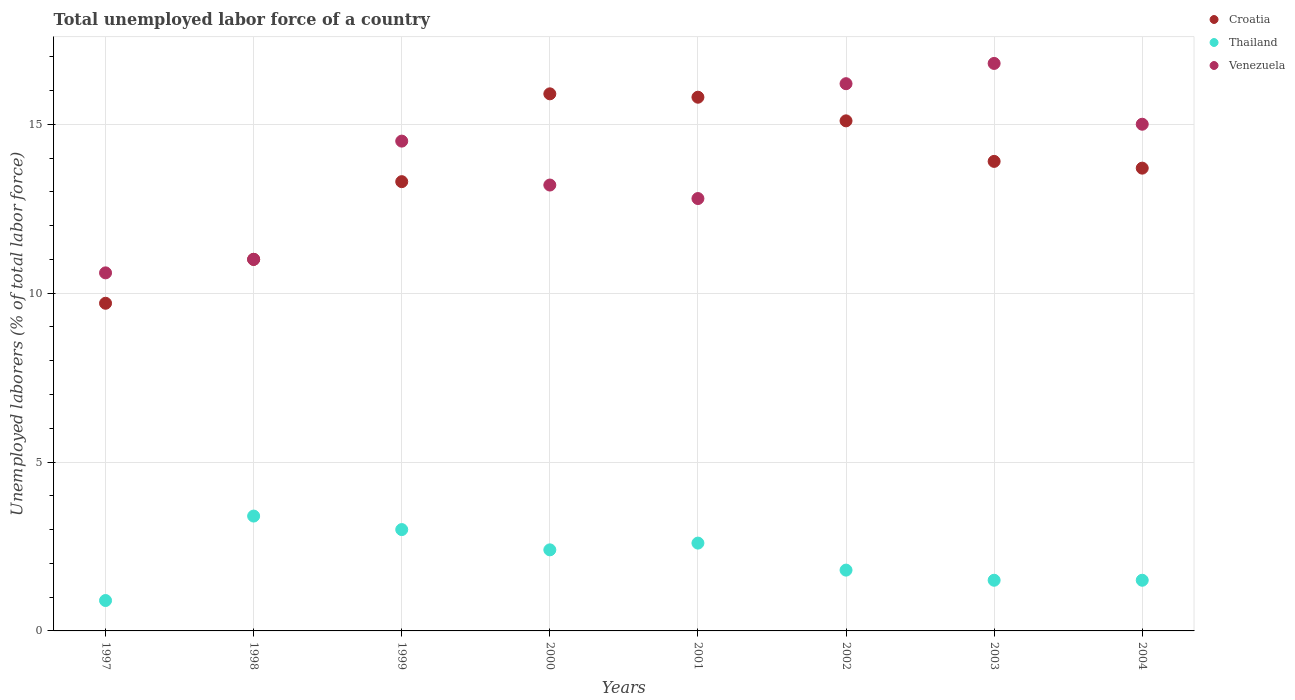Across all years, what is the maximum total unemployed labor force in Thailand?
Your response must be concise. 3.4. Across all years, what is the minimum total unemployed labor force in Croatia?
Provide a short and direct response. 9.7. In which year was the total unemployed labor force in Croatia maximum?
Make the answer very short. 2000. In which year was the total unemployed labor force in Thailand minimum?
Offer a very short reply. 1997. What is the total total unemployed labor force in Croatia in the graph?
Offer a very short reply. 108.4. What is the difference between the total unemployed labor force in Croatia in 2001 and that in 2003?
Your answer should be very brief. 1.9. What is the difference between the total unemployed labor force in Croatia in 1997 and the total unemployed labor force in Venezuela in 2001?
Make the answer very short. -3.1. What is the average total unemployed labor force in Venezuela per year?
Your answer should be very brief. 13.76. In how many years, is the total unemployed labor force in Thailand greater than 16 %?
Provide a succinct answer. 0. What is the ratio of the total unemployed labor force in Thailand in 2001 to that in 2003?
Provide a short and direct response. 1.73. Is the difference between the total unemployed labor force in Thailand in 1998 and 2003 greater than the difference between the total unemployed labor force in Venezuela in 1998 and 2003?
Your answer should be compact. Yes. What is the difference between the highest and the second highest total unemployed labor force in Croatia?
Make the answer very short. 0.1. What is the difference between the highest and the lowest total unemployed labor force in Thailand?
Ensure brevity in your answer.  2.5. In how many years, is the total unemployed labor force in Croatia greater than the average total unemployed labor force in Croatia taken over all years?
Ensure brevity in your answer.  5. Is the sum of the total unemployed labor force in Venezuela in 1999 and 2000 greater than the maximum total unemployed labor force in Croatia across all years?
Provide a short and direct response. Yes. Does the total unemployed labor force in Thailand monotonically increase over the years?
Provide a short and direct response. No. Is the total unemployed labor force in Thailand strictly greater than the total unemployed labor force in Croatia over the years?
Your answer should be compact. No. How many dotlines are there?
Provide a short and direct response. 3. How many years are there in the graph?
Make the answer very short. 8. What is the difference between two consecutive major ticks on the Y-axis?
Your answer should be very brief. 5. Does the graph contain grids?
Provide a short and direct response. Yes. Where does the legend appear in the graph?
Ensure brevity in your answer.  Top right. How are the legend labels stacked?
Offer a very short reply. Vertical. What is the title of the graph?
Your response must be concise. Total unemployed labor force of a country. What is the label or title of the Y-axis?
Provide a short and direct response. Unemployed laborers (% of total labor force). What is the Unemployed laborers (% of total labor force) of Croatia in 1997?
Provide a succinct answer. 9.7. What is the Unemployed laborers (% of total labor force) of Thailand in 1997?
Provide a short and direct response. 0.9. What is the Unemployed laborers (% of total labor force) of Venezuela in 1997?
Make the answer very short. 10.6. What is the Unemployed laborers (% of total labor force) in Croatia in 1998?
Keep it short and to the point. 11. What is the Unemployed laborers (% of total labor force) in Thailand in 1998?
Ensure brevity in your answer.  3.4. What is the Unemployed laborers (% of total labor force) of Venezuela in 1998?
Keep it short and to the point. 11. What is the Unemployed laborers (% of total labor force) of Croatia in 1999?
Provide a succinct answer. 13.3. What is the Unemployed laborers (% of total labor force) in Thailand in 1999?
Offer a terse response. 3. What is the Unemployed laborers (% of total labor force) in Croatia in 2000?
Keep it short and to the point. 15.9. What is the Unemployed laborers (% of total labor force) in Thailand in 2000?
Provide a succinct answer. 2.4. What is the Unemployed laborers (% of total labor force) in Venezuela in 2000?
Your response must be concise. 13.2. What is the Unemployed laborers (% of total labor force) of Croatia in 2001?
Your answer should be very brief. 15.8. What is the Unemployed laborers (% of total labor force) of Thailand in 2001?
Your response must be concise. 2.6. What is the Unemployed laborers (% of total labor force) of Venezuela in 2001?
Your response must be concise. 12.8. What is the Unemployed laborers (% of total labor force) of Croatia in 2002?
Offer a very short reply. 15.1. What is the Unemployed laborers (% of total labor force) in Thailand in 2002?
Your answer should be very brief. 1.8. What is the Unemployed laborers (% of total labor force) of Venezuela in 2002?
Your response must be concise. 16.2. What is the Unemployed laborers (% of total labor force) of Croatia in 2003?
Make the answer very short. 13.9. What is the Unemployed laborers (% of total labor force) in Venezuela in 2003?
Ensure brevity in your answer.  16.8. What is the Unemployed laborers (% of total labor force) of Croatia in 2004?
Provide a short and direct response. 13.7. Across all years, what is the maximum Unemployed laborers (% of total labor force) of Croatia?
Your answer should be compact. 15.9. Across all years, what is the maximum Unemployed laborers (% of total labor force) of Thailand?
Give a very brief answer. 3.4. Across all years, what is the maximum Unemployed laborers (% of total labor force) of Venezuela?
Make the answer very short. 16.8. Across all years, what is the minimum Unemployed laborers (% of total labor force) of Croatia?
Your response must be concise. 9.7. Across all years, what is the minimum Unemployed laborers (% of total labor force) in Thailand?
Your answer should be compact. 0.9. Across all years, what is the minimum Unemployed laborers (% of total labor force) in Venezuela?
Make the answer very short. 10.6. What is the total Unemployed laborers (% of total labor force) of Croatia in the graph?
Your answer should be very brief. 108.4. What is the total Unemployed laborers (% of total labor force) in Venezuela in the graph?
Offer a very short reply. 110.1. What is the difference between the Unemployed laborers (% of total labor force) in Thailand in 1997 and that in 1998?
Provide a short and direct response. -2.5. What is the difference between the Unemployed laborers (% of total labor force) in Venezuela in 1997 and that in 1998?
Your answer should be very brief. -0.4. What is the difference between the Unemployed laborers (% of total labor force) in Thailand in 1997 and that in 1999?
Provide a short and direct response. -2.1. What is the difference between the Unemployed laborers (% of total labor force) of Venezuela in 1997 and that in 1999?
Provide a succinct answer. -3.9. What is the difference between the Unemployed laborers (% of total labor force) in Thailand in 1997 and that in 2000?
Provide a succinct answer. -1.5. What is the difference between the Unemployed laborers (% of total labor force) of Venezuela in 1997 and that in 2000?
Keep it short and to the point. -2.6. What is the difference between the Unemployed laborers (% of total labor force) in Croatia in 1997 and that in 2001?
Your answer should be compact. -6.1. What is the difference between the Unemployed laborers (% of total labor force) of Thailand in 1997 and that in 2001?
Provide a succinct answer. -1.7. What is the difference between the Unemployed laborers (% of total labor force) of Venezuela in 1997 and that in 2002?
Your response must be concise. -5.6. What is the difference between the Unemployed laborers (% of total labor force) in Croatia in 1997 and that in 2003?
Give a very brief answer. -4.2. What is the difference between the Unemployed laborers (% of total labor force) in Thailand in 1997 and that in 2003?
Your answer should be compact. -0.6. What is the difference between the Unemployed laborers (% of total labor force) of Croatia in 1997 and that in 2004?
Keep it short and to the point. -4. What is the difference between the Unemployed laborers (% of total labor force) of Venezuela in 1997 and that in 2004?
Keep it short and to the point. -4.4. What is the difference between the Unemployed laborers (% of total labor force) of Thailand in 1998 and that in 1999?
Offer a terse response. 0.4. What is the difference between the Unemployed laborers (% of total labor force) of Croatia in 1998 and that in 2001?
Offer a very short reply. -4.8. What is the difference between the Unemployed laborers (% of total labor force) in Croatia in 1998 and that in 2002?
Your answer should be very brief. -4.1. What is the difference between the Unemployed laborers (% of total labor force) in Venezuela in 1998 and that in 2002?
Provide a short and direct response. -5.2. What is the difference between the Unemployed laborers (% of total labor force) of Croatia in 1998 and that in 2004?
Keep it short and to the point. -2.7. What is the difference between the Unemployed laborers (% of total labor force) in Venezuela in 1998 and that in 2004?
Provide a succinct answer. -4. What is the difference between the Unemployed laborers (% of total labor force) of Thailand in 1999 and that in 2000?
Ensure brevity in your answer.  0.6. What is the difference between the Unemployed laborers (% of total labor force) in Croatia in 1999 and that in 2001?
Provide a succinct answer. -2.5. What is the difference between the Unemployed laborers (% of total labor force) of Thailand in 1999 and that in 2002?
Offer a terse response. 1.2. What is the difference between the Unemployed laborers (% of total labor force) of Croatia in 1999 and that in 2003?
Provide a short and direct response. -0.6. What is the difference between the Unemployed laborers (% of total labor force) of Venezuela in 1999 and that in 2003?
Provide a short and direct response. -2.3. What is the difference between the Unemployed laborers (% of total labor force) of Thailand in 1999 and that in 2004?
Your response must be concise. 1.5. What is the difference between the Unemployed laborers (% of total labor force) in Venezuela in 1999 and that in 2004?
Ensure brevity in your answer.  -0.5. What is the difference between the Unemployed laborers (% of total labor force) of Thailand in 2000 and that in 2002?
Your answer should be compact. 0.6. What is the difference between the Unemployed laborers (% of total labor force) of Venezuela in 2000 and that in 2002?
Offer a very short reply. -3. What is the difference between the Unemployed laborers (% of total labor force) in Croatia in 2000 and that in 2003?
Your response must be concise. 2. What is the difference between the Unemployed laborers (% of total labor force) of Venezuela in 2000 and that in 2003?
Your answer should be very brief. -3.6. What is the difference between the Unemployed laborers (% of total labor force) in Croatia in 2000 and that in 2004?
Your response must be concise. 2.2. What is the difference between the Unemployed laborers (% of total labor force) in Thailand in 2000 and that in 2004?
Offer a terse response. 0.9. What is the difference between the Unemployed laborers (% of total labor force) in Venezuela in 2000 and that in 2004?
Offer a terse response. -1.8. What is the difference between the Unemployed laborers (% of total labor force) of Thailand in 2001 and that in 2002?
Give a very brief answer. 0.8. What is the difference between the Unemployed laborers (% of total labor force) of Venezuela in 2001 and that in 2002?
Give a very brief answer. -3.4. What is the difference between the Unemployed laborers (% of total labor force) of Croatia in 2001 and that in 2003?
Ensure brevity in your answer.  1.9. What is the difference between the Unemployed laborers (% of total labor force) in Thailand in 2001 and that in 2003?
Provide a succinct answer. 1.1. What is the difference between the Unemployed laborers (% of total labor force) in Thailand in 2002 and that in 2003?
Offer a very short reply. 0.3. What is the difference between the Unemployed laborers (% of total labor force) in Croatia in 2002 and that in 2004?
Give a very brief answer. 1.4. What is the difference between the Unemployed laborers (% of total labor force) of Venezuela in 2002 and that in 2004?
Offer a terse response. 1.2. What is the difference between the Unemployed laborers (% of total labor force) in Thailand in 2003 and that in 2004?
Provide a succinct answer. 0. What is the difference between the Unemployed laborers (% of total labor force) in Thailand in 1997 and the Unemployed laborers (% of total labor force) in Venezuela in 1998?
Keep it short and to the point. -10.1. What is the difference between the Unemployed laborers (% of total labor force) in Croatia in 1997 and the Unemployed laborers (% of total labor force) in Thailand in 1999?
Provide a short and direct response. 6.7. What is the difference between the Unemployed laborers (% of total labor force) in Croatia in 1997 and the Unemployed laborers (% of total labor force) in Venezuela in 1999?
Make the answer very short. -4.8. What is the difference between the Unemployed laborers (% of total labor force) in Thailand in 1997 and the Unemployed laborers (% of total labor force) in Venezuela in 1999?
Your answer should be very brief. -13.6. What is the difference between the Unemployed laborers (% of total labor force) in Croatia in 1997 and the Unemployed laborers (% of total labor force) in Venezuela in 2000?
Ensure brevity in your answer.  -3.5. What is the difference between the Unemployed laborers (% of total labor force) of Thailand in 1997 and the Unemployed laborers (% of total labor force) of Venezuela in 2001?
Offer a very short reply. -11.9. What is the difference between the Unemployed laborers (% of total labor force) in Croatia in 1997 and the Unemployed laborers (% of total labor force) in Thailand in 2002?
Provide a succinct answer. 7.9. What is the difference between the Unemployed laborers (% of total labor force) in Croatia in 1997 and the Unemployed laborers (% of total labor force) in Venezuela in 2002?
Your answer should be compact. -6.5. What is the difference between the Unemployed laborers (% of total labor force) of Thailand in 1997 and the Unemployed laborers (% of total labor force) of Venezuela in 2002?
Make the answer very short. -15.3. What is the difference between the Unemployed laborers (% of total labor force) in Croatia in 1997 and the Unemployed laborers (% of total labor force) in Venezuela in 2003?
Your response must be concise. -7.1. What is the difference between the Unemployed laborers (% of total labor force) in Thailand in 1997 and the Unemployed laborers (% of total labor force) in Venezuela in 2003?
Provide a short and direct response. -15.9. What is the difference between the Unemployed laborers (% of total labor force) in Croatia in 1997 and the Unemployed laborers (% of total labor force) in Venezuela in 2004?
Give a very brief answer. -5.3. What is the difference between the Unemployed laborers (% of total labor force) in Thailand in 1997 and the Unemployed laborers (% of total labor force) in Venezuela in 2004?
Keep it short and to the point. -14.1. What is the difference between the Unemployed laborers (% of total labor force) in Croatia in 1998 and the Unemployed laborers (% of total labor force) in Venezuela in 1999?
Provide a short and direct response. -3.5. What is the difference between the Unemployed laborers (% of total labor force) in Thailand in 1998 and the Unemployed laborers (% of total labor force) in Venezuela in 1999?
Your answer should be very brief. -11.1. What is the difference between the Unemployed laborers (% of total labor force) in Croatia in 1998 and the Unemployed laborers (% of total labor force) in Venezuela in 2000?
Your response must be concise. -2.2. What is the difference between the Unemployed laborers (% of total labor force) of Croatia in 1998 and the Unemployed laborers (% of total labor force) of Venezuela in 2001?
Provide a succinct answer. -1.8. What is the difference between the Unemployed laborers (% of total labor force) in Croatia in 1998 and the Unemployed laborers (% of total labor force) in Thailand in 2002?
Your response must be concise. 9.2. What is the difference between the Unemployed laborers (% of total labor force) of Thailand in 1998 and the Unemployed laborers (% of total labor force) of Venezuela in 2002?
Your response must be concise. -12.8. What is the difference between the Unemployed laborers (% of total labor force) of Croatia in 1998 and the Unemployed laborers (% of total labor force) of Venezuela in 2003?
Your response must be concise. -5.8. What is the difference between the Unemployed laborers (% of total labor force) of Croatia in 1998 and the Unemployed laborers (% of total labor force) of Thailand in 2004?
Make the answer very short. 9.5. What is the difference between the Unemployed laborers (% of total labor force) in Thailand in 1998 and the Unemployed laborers (% of total labor force) in Venezuela in 2004?
Keep it short and to the point. -11.6. What is the difference between the Unemployed laborers (% of total labor force) of Croatia in 1999 and the Unemployed laborers (% of total labor force) of Thailand in 2000?
Your answer should be very brief. 10.9. What is the difference between the Unemployed laborers (% of total labor force) in Croatia in 1999 and the Unemployed laborers (% of total labor force) in Thailand in 2001?
Make the answer very short. 10.7. What is the difference between the Unemployed laborers (% of total labor force) of Croatia in 1999 and the Unemployed laborers (% of total labor force) of Venezuela in 2001?
Give a very brief answer. 0.5. What is the difference between the Unemployed laborers (% of total labor force) in Croatia in 1999 and the Unemployed laborers (% of total labor force) in Venezuela in 2002?
Provide a succinct answer. -2.9. What is the difference between the Unemployed laborers (% of total labor force) in Thailand in 1999 and the Unemployed laborers (% of total labor force) in Venezuela in 2002?
Offer a terse response. -13.2. What is the difference between the Unemployed laborers (% of total labor force) of Croatia in 1999 and the Unemployed laborers (% of total labor force) of Thailand in 2003?
Provide a succinct answer. 11.8. What is the difference between the Unemployed laborers (% of total labor force) of Croatia in 1999 and the Unemployed laborers (% of total labor force) of Venezuela in 2003?
Provide a succinct answer. -3.5. What is the difference between the Unemployed laborers (% of total labor force) in Thailand in 1999 and the Unemployed laborers (% of total labor force) in Venezuela in 2003?
Offer a very short reply. -13.8. What is the difference between the Unemployed laborers (% of total labor force) of Croatia in 1999 and the Unemployed laborers (% of total labor force) of Thailand in 2004?
Give a very brief answer. 11.8. What is the difference between the Unemployed laborers (% of total labor force) in Croatia in 1999 and the Unemployed laborers (% of total labor force) in Venezuela in 2004?
Provide a short and direct response. -1.7. What is the difference between the Unemployed laborers (% of total labor force) of Thailand in 2000 and the Unemployed laborers (% of total labor force) of Venezuela in 2001?
Your response must be concise. -10.4. What is the difference between the Unemployed laborers (% of total labor force) of Croatia in 2000 and the Unemployed laborers (% of total labor force) of Thailand in 2003?
Offer a terse response. 14.4. What is the difference between the Unemployed laborers (% of total labor force) in Thailand in 2000 and the Unemployed laborers (% of total labor force) in Venezuela in 2003?
Ensure brevity in your answer.  -14.4. What is the difference between the Unemployed laborers (% of total labor force) in Croatia in 2000 and the Unemployed laborers (% of total labor force) in Thailand in 2004?
Your answer should be compact. 14.4. What is the difference between the Unemployed laborers (% of total labor force) of Croatia in 2000 and the Unemployed laborers (% of total labor force) of Venezuela in 2004?
Keep it short and to the point. 0.9. What is the difference between the Unemployed laborers (% of total labor force) in Thailand in 2000 and the Unemployed laborers (% of total labor force) in Venezuela in 2004?
Keep it short and to the point. -12.6. What is the difference between the Unemployed laborers (% of total labor force) of Croatia in 2001 and the Unemployed laborers (% of total labor force) of Thailand in 2002?
Offer a very short reply. 14. What is the difference between the Unemployed laborers (% of total labor force) in Croatia in 2001 and the Unemployed laborers (% of total labor force) in Venezuela in 2003?
Give a very brief answer. -1. What is the difference between the Unemployed laborers (% of total labor force) of Croatia in 2002 and the Unemployed laborers (% of total labor force) of Venezuela in 2003?
Provide a succinct answer. -1.7. What is the difference between the Unemployed laborers (% of total labor force) in Thailand in 2002 and the Unemployed laborers (% of total labor force) in Venezuela in 2003?
Offer a very short reply. -15. What is the difference between the Unemployed laborers (% of total labor force) of Croatia in 2002 and the Unemployed laborers (% of total labor force) of Thailand in 2004?
Make the answer very short. 13.6. What is the difference between the Unemployed laborers (% of total labor force) in Croatia in 2002 and the Unemployed laborers (% of total labor force) in Venezuela in 2004?
Your answer should be very brief. 0.1. What is the difference between the Unemployed laborers (% of total labor force) in Croatia in 2003 and the Unemployed laborers (% of total labor force) in Thailand in 2004?
Your response must be concise. 12.4. What is the average Unemployed laborers (% of total labor force) of Croatia per year?
Ensure brevity in your answer.  13.55. What is the average Unemployed laborers (% of total labor force) in Thailand per year?
Make the answer very short. 2.14. What is the average Unemployed laborers (% of total labor force) in Venezuela per year?
Your response must be concise. 13.76. In the year 1997, what is the difference between the Unemployed laborers (% of total labor force) in Croatia and Unemployed laborers (% of total labor force) in Thailand?
Your answer should be very brief. 8.8. In the year 1997, what is the difference between the Unemployed laborers (% of total labor force) in Croatia and Unemployed laborers (% of total labor force) in Venezuela?
Provide a succinct answer. -0.9. In the year 1997, what is the difference between the Unemployed laborers (% of total labor force) of Thailand and Unemployed laborers (% of total labor force) of Venezuela?
Provide a succinct answer. -9.7. In the year 1998, what is the difference between the Unemployed laborers (% of total labor force) of Thailand and Unemployed laborers (% of total labor force) of Venezuela?
Offer a terse response. -7.6. In the year 1999, what is the difference between the Unemployed laborers (% of total labor force) in Croatia and Unemployed laborers (% of total labor force) in Venezuela?
Provide a succinct answer. -1.2. In the year 1999, what is the difference between the Unemployed laborers (% of total labor force) in Thailand and Unemployed laborers (% of total labor force) in Venezuela?
Make the answer very short. -11.5. In the year 2000, what is the difference between the Unemployed laborers (% of total labor force) in Croatia and Unemployed laborers (% of total labor force) in Thailand?
Your response must be concise. 13.5. In the year 2000, what is the difference between the Unemployed laborers (% of total labor force) in Croatia and Unemployed laborers (% of total labor force) in Venezuela?
Offer a very short reply. 2.7. In the year 2002, what is the difference between the Unemployed laborers (% of total labor force) of Croatia and Unemployed laborers (% of total labor force) of Venezuela?
Your response must be concise. -1.1. In the year 2002, what is the difference between the Unemployed laborers (% of total labor force) in Thailand and Unemployed laborers (% of total labor force) in Venezuela?
Offer a terse response. -14.4. In the year 2003, what is the difference between the Unemployed laborers (% of total labor force) in Thailand and Unemployed laborers (% of total labor force) in Venezuela?
Keep it short and to the point. -15.3. In the year 2004, what is the difference between the Unemployed laborers (% of total labor force) in Croatia and Unemployed laborers (% of total labor force) in Thailand?
Keep it short and to the point. 12.2. In the year 2004, what is the difference between the Unemployed laborers (% of total labor force) of Thailand and Unemployed laborers (% of total labor force) of Venezuela?
Provide a short and direct response. -13.5. What is the ratio of the Unemployed laborers (% of total labor force) in Croatia in 1997 to that in 1998?
Your response must be concise. 0.88. What is the ratio of the Unemployed laborers (% of total labor force) of Thailand in 1997 to that in 1998?
Your response must be concise. 0.26. What is the ratio of the Unemployed laborers (% of total labor force) of Venezuela in 1997 to that in 1998?
Offer a very short reply. 0.96. What is the ratio of the Unemployed laborers (% of total labor force) of Croatia in 1997 to that in 1999?
Your answer should be very brief. 0.73. What is the ratio of the Unemployed laborers (% of total labor force) in Thailand in 1997 to that in 1999?
Give a very brief answer. 0.3. What is the ratio of the Unemployed laborers (% of total labor force) of Venezuela in 1997 to that in 1999?
Provide a short and direct response. 0.73. What is the ratio of the Unemployed laborers (% of total labor force) of Croatia in 1997 to that in 2000?
Your response must be concise. 0.61. What is the ratio of the Unemployed laborers (% of total labor force) in Venezuela in 1997 to that in 2000?
Your response must be concise. 0.8. What is the ratio of the Unemployed laborers (% of total labor force) in Croatia in 1997 to that in 2001?
Your answer should be very brief. 0.61. What is the ratio of the Unemployed laborers (% of total labor force) in Thailand in 1997 to that in 2001?
Provide a succinct answer. 0.35. What is the ratio of the Unemployed laborers (% of total labor force) of Venezuela in 1997 to that in 2001?
Your answer should be very brief. 0.83. What is the ratio of the Unemployed laborers (% of total labor force) of Croatia in 1997 to that in 2002?
Your answer should be compact. 0.64. What is the ratio of the Unemployed laborers (% of total labor force) in Thailand in 1997 to that in 2002?
Your answer should be very brief. 0.5. What is the ratio of the Unemployed laborers (% of total labor force) in Venezuela in 1997 to that in 2002?
Provide a short and direct response. 0.65. What is the ratio of the Unemployed laborers (% of total labor force) in Croatia in 1997 to that in 2003?
Your answer should be compact. 0.7. What is the ratio of the Unemployed laborers (% of total labor force) of Venezuela in 1997 to that in 2003?
Give a very brief answer. 0.63. What is the ratio of the Unemployed laborers (% of total labor force) of Croatia in 1997 to that in 2004?
Offer a terse response. 0.71. What is the ratio of the Unemployed laborers (% of total labor force) of Venezuela in 1997 to that in 2004?
Your response must be concise. 0.71. What is the ratio of the Unemployed laborers (% of total labor force) of Croatia in 1998 to that in 1999?
Keep it short and to the point. 0.83. What is the ratio of the Unemployed laborers (% of total labor force) of Thailand in 1998 to that in 1999?
Your answer should be very brief. 1.13. What is the ratio of the Unemployed laborers (% of total labor force) in Venezuela in 1998 to that in 1999?
Provide a short and direct response. 0.76. What is the ratio of the Unemployed laborers (% of total labor force) of Croatia in 1998 to that in 2000?
Offer a very short reply. 0.69. What is the ratio of the Unemployed laborers (% of total labor force) in Thailand in 1998 to that in 2000?
Provide a short and direct response. 1.42. What is the ratio of the Unemployed laborers (% of total labor force) in Croatia in 1998 to that in 2001?
Ensure brevity in your answer.  0.7. What is the ratio of the Unemployed laborers (% of total labor force) in Thailand in 1998 to that in 2001?
Your answer should be very brief. 1.31. What is the ratio of the Unemployed laborers (% of total labor force) in Venezuela in 1998 to that in 2001?
Give a very brief answer. 0.86. What is the ratio of the Unemployed laborers (% of total labor force) of Croatia in 1998 to that in 2002?
Give a very brief answer. 0.73. What is the ratio of the Unemployed laborers (% of total labor force) of Thailand in 1998 to that in 2002?
Give a very brief answer. 1.89. What is the ratio of the Unemployed laborers (% of total labor force) of Venezuela in 1998 to that in 2002?
Provide a succinct answer. 0.68. What is the ratio of the Unemployed laborers (% of total labor force) in Croatia in 1998 to that in 2003?
Your response must be concise. 0.79. What is the ratio of the Unemployed laborers (% of total labor force) in Thailand in 1998 to that in 2003?
Your answer should be compact. 2.27. What is the ratio of the Unemployed laborers (% of total labor force) in Venezuela in 1998 to that in 2003?
Your answer should be compact. 0.65. What is the ratio of the Unemployed laborers (% of total labor force) of Croatia in 1998 to that in 2004?
Your response must be concise. 0.8. What is the ratio of the Unemployed laborers (% of total labor force) in Thailand in 1998 to that in 2004?
Offer a terse response. 2.27. What is the ratio of the Unemployed laborers (% of total labor force) in Venezuela in 1998 to that in 2004?
Your response must be concise. 0.73. What is the ratio of the Unemployed laborers (% of total labor force) in Croatia in 1999 to that in 2000?
Make the answer very short. 0.84. What is the ratio of the Unemployed laborers (% of total labor force) in Thailand in 1999 to that in 2000?
Provide a short and direct response. 1.25. What is the ratio of the Unemployed laborers (% of total labor force) of Venezuela in 1999 to that in 2000?
Provide a short and direct response. 1.1. What is the ratio of the Unemployed laborers (% of total labor force) of Croatia in 1999 to that in 2001?
Your answer should be compact. 0.84. What is the ratio of the Unemployed laborers (% of total labor force) in Thailand in 1999 to that in 2001?
Ensure brevity in your answer.  1.15. What is the ratio of the Unemployed laborers (% of total labor force) in Venezuela in 1999 to that in 2001?
Offer a very short reply. 1.13. What is the ratio of the Unemployed laborers (% of total labor force) of Croatia in 1999 to that in 2002?
Offer a terse response. 0.88. What is the ratio of the Unemployed laborers (% of total labor force) of Venezuela in 1999 to that in 2002?
Ensure brevity in your answer.  0.9. What is the ratio of the Unemployed laborers (% of total labor force) in Croatia in 1999 to that in 2003?
Offer a terse response. 0.96. What is the ratio of the Unemployed laborers (% of total labor force) in Thailand in 1999 to that in 2003?
Your answer should be very brief. 2. What is the ratio of the Unemployed laborers (% of total labor force) in Venezuela in 1999 to that in 2003?
Your response must be concise. 0.86. What is the ratio of the Unemployed laborers (% of total labor force) of Croatia in 1999 to that in 2004?
Ensure brevity in your answer.  0.97. What is the ratio of the Unemployed laborers (% of total labor force) in Venezuela in 1999 to that in 2004?
Offer a terse response. 0.97. What is the ratio of the Unemployed laborers (% of total labor force) of Thailand in 2000 to that in 2001?
Make the answer very short. 0.92. What is the ratio of the Unemployed laborers (% of total labor force) in Venezuela in 2000 to that in 2001?
Provide a succinct answer. 1.03. What is the ratio of the Unemployed laborers (% of total labor force) in Croatia in 2000 to that in 2002?
Your answer should be compact. 1.05. What is the ratio of the Unemployed laborers (% of total labor force) of Thailand in 2000 to that in 2002?
Provide a short and direct response. 1.33. What is the ratio of the Unemployed laborers (% of total labor force) of Venezuela in 2000 to that in 2002?
Keep it short and to the point. 0.81. What is the ratio of the Unemployed laborers (% of total labor force) in Croatia in 2000 to that in 2003?
Your answer should be compact. 1.14. What is the ratio of the Unemployed laborers (% of total labor force) in Venezuela in 2000 to that in 2003?
Your answer should be very brief. 0.79. What is the ratio of the Unemployed laborers (% of total labor force) of Croatia in 2000 to that in 2004?
Give a very brief answer. 1.16. What is the ratio of the Unemployed laborers (% of total labor force) of Thailand in 2000 to that in 2004?
Provide a succinct answer. 1.6. What is the ratio of the Unemployed laborers (% of total labor force) of Croatia in 2001 to that in 2002?
Your response must be concise. 1.05. What is the ratio of the Unemployed laborers (% of total labor force) in Thailand in 2001 to that in 2002?
Provide a succinct answer. 1.44. What is the ratio of the Unemployed laborers (% of total labor force) of Venezuela in 2001 to that in 2002?
Offer a very short reply. 0.79. What is the ratio of the Unemployed laborers (% of total labor force) of Croatia in 2001 to that in 2003?
Offer a terse response. 1.14. What is the ratio of the Unemployed laborers (% of total labor force) of Thailand in 2001 to that in 2003?
Ensure brevity in your answer.  1.73. What is the ratio of the Unemployed laborers (% of total labor force) in Venezuela in 2001 to that in 2003?
Provide a short and direct response. 0.76. What is the ratio of the Unemployed laborers (% of total labor force) of Croatia in 2001 to that in 2004?
Ensure brevity in your answer.  1.15. What is the ratio of the Unemployed laborers (% of total labor force) of Thailand in 2001 to that in 2004?
Keep it short and to the point. 1.73. What is the ratio of the Unemployed laborers (% of total labor force) of Venezuela in 2001 to that in 2004?
Your answer should be very brief. 0.85. What is the ratio of the Unemployed laborers (% of total labor force) of Croatia in 2002 to that in 2003?
Your answer should be compact. 1.09. What is the ratio of the Unemployed laborers (% of total labor force) of Thailand in 2002 to that in 2003?
Keep it short and to the point. 1.2. What is the ratio of the Unemployed laborers (% of total labor force) of Croatia in 2002 to that in 2004?
Keep it short and to the point. 1.1. What is the ratio of the Unemployed laborers (% of total labor force) in Thailand in 2002 to that in 2004?
Provide a short and direct response. 1.2. What is the ratio of the Unemployed laborers (% of total labor force) of Venezuela in 2002 to that in 2004?
Your answer should be very brief. 1.08. What is the ratio of the Unemployed laborers (% of total labor force) in Croatia in 2003 to that in 2004?
Provide a succinct answer. 1.01. What is the ratio of the Unemployed laborers (% of total labor force) of Thailand in 2003 to that in 2004?
Your answer should be compact. 1. What is the ratio of the Unemployed laborers (% of total labor force) of Venezuela in 2003 to that in 2004?
Keep it short and to the point. 1.12. What is the difference between the highest and the second highest Unemployed laborers (% of total labor force) in Croatia?
Provide a short and direct response. 0.1. What is the difference between the highest and the second highest Unemployed laborers (% of total labor force) of Venezuela?
Provide a succinct answer. 0.6. What is the difference between the highest and the lowest Unemployed laborers (% of total labor force) in Croatia?
Your answer should be very brief. 6.2. 